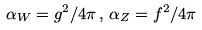<formula> <loc_0><loc_0><loc_500><loc_500>\alpha _ { W } = g ^ { 2 } / 4 \pi \, , \, \alpha _ { Z } = f ^ { 2 } / 4 \pi</formula> 